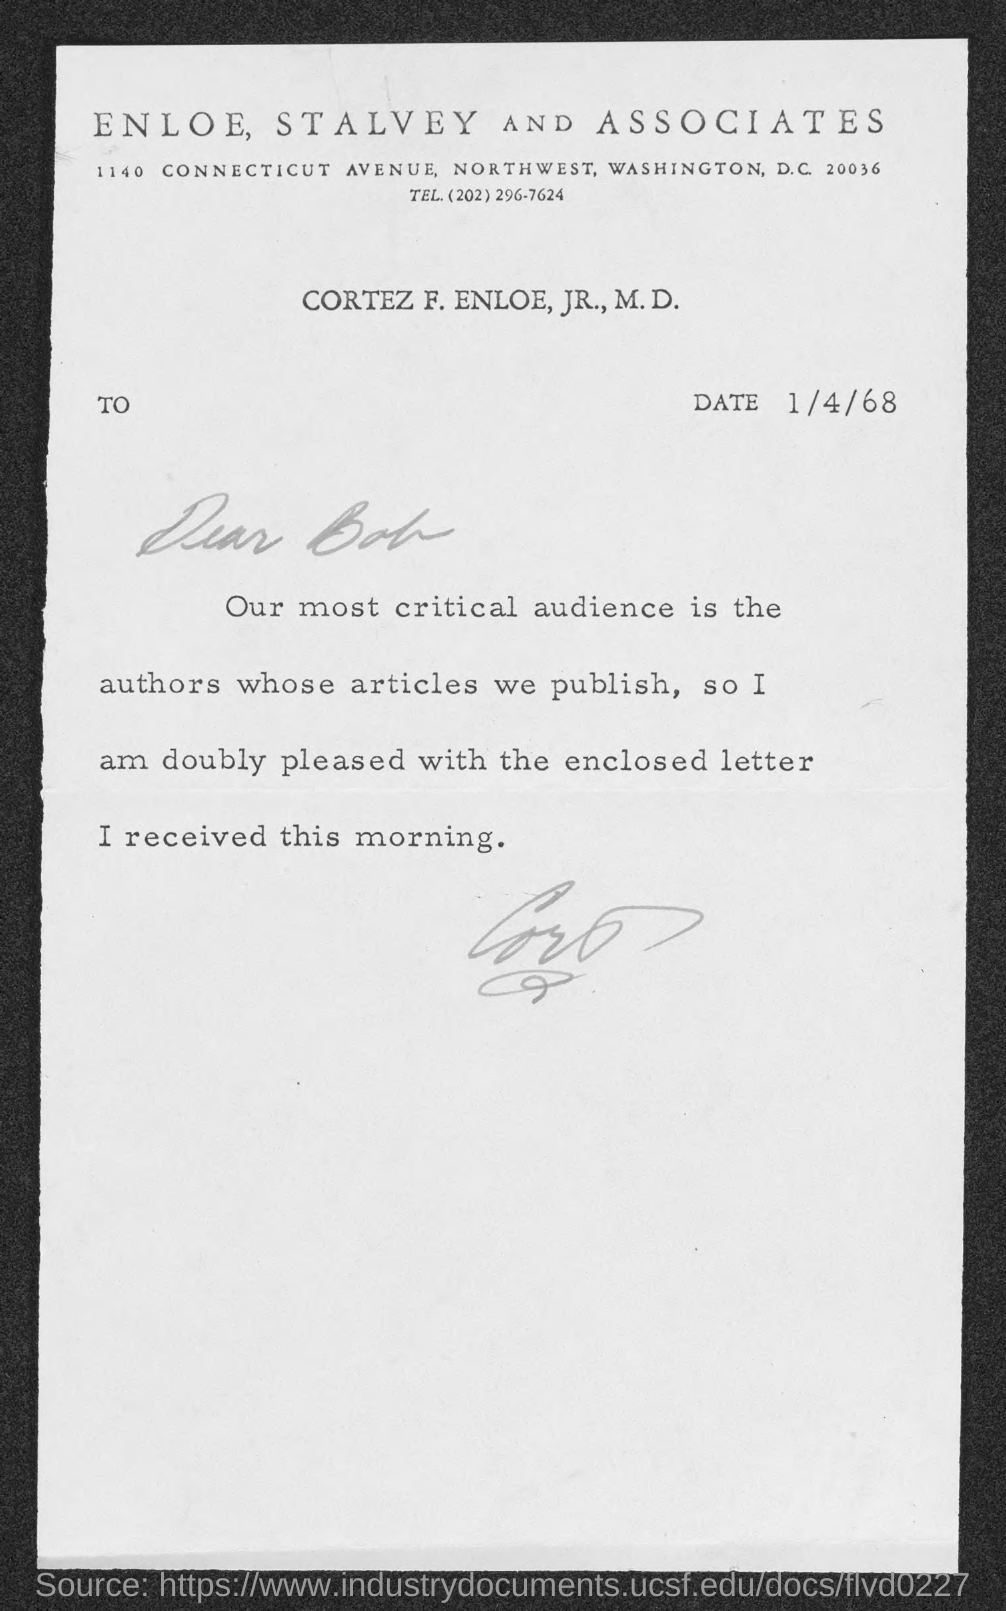What is the telephone number of enloe, stalvey and associates?
Provide a succinct answer. (202)296-7624. On which date the letter is dated on?
Make the answer very short. 1/4/68. To whom this letter is written to?
Provide a short and direct response. Bob. 